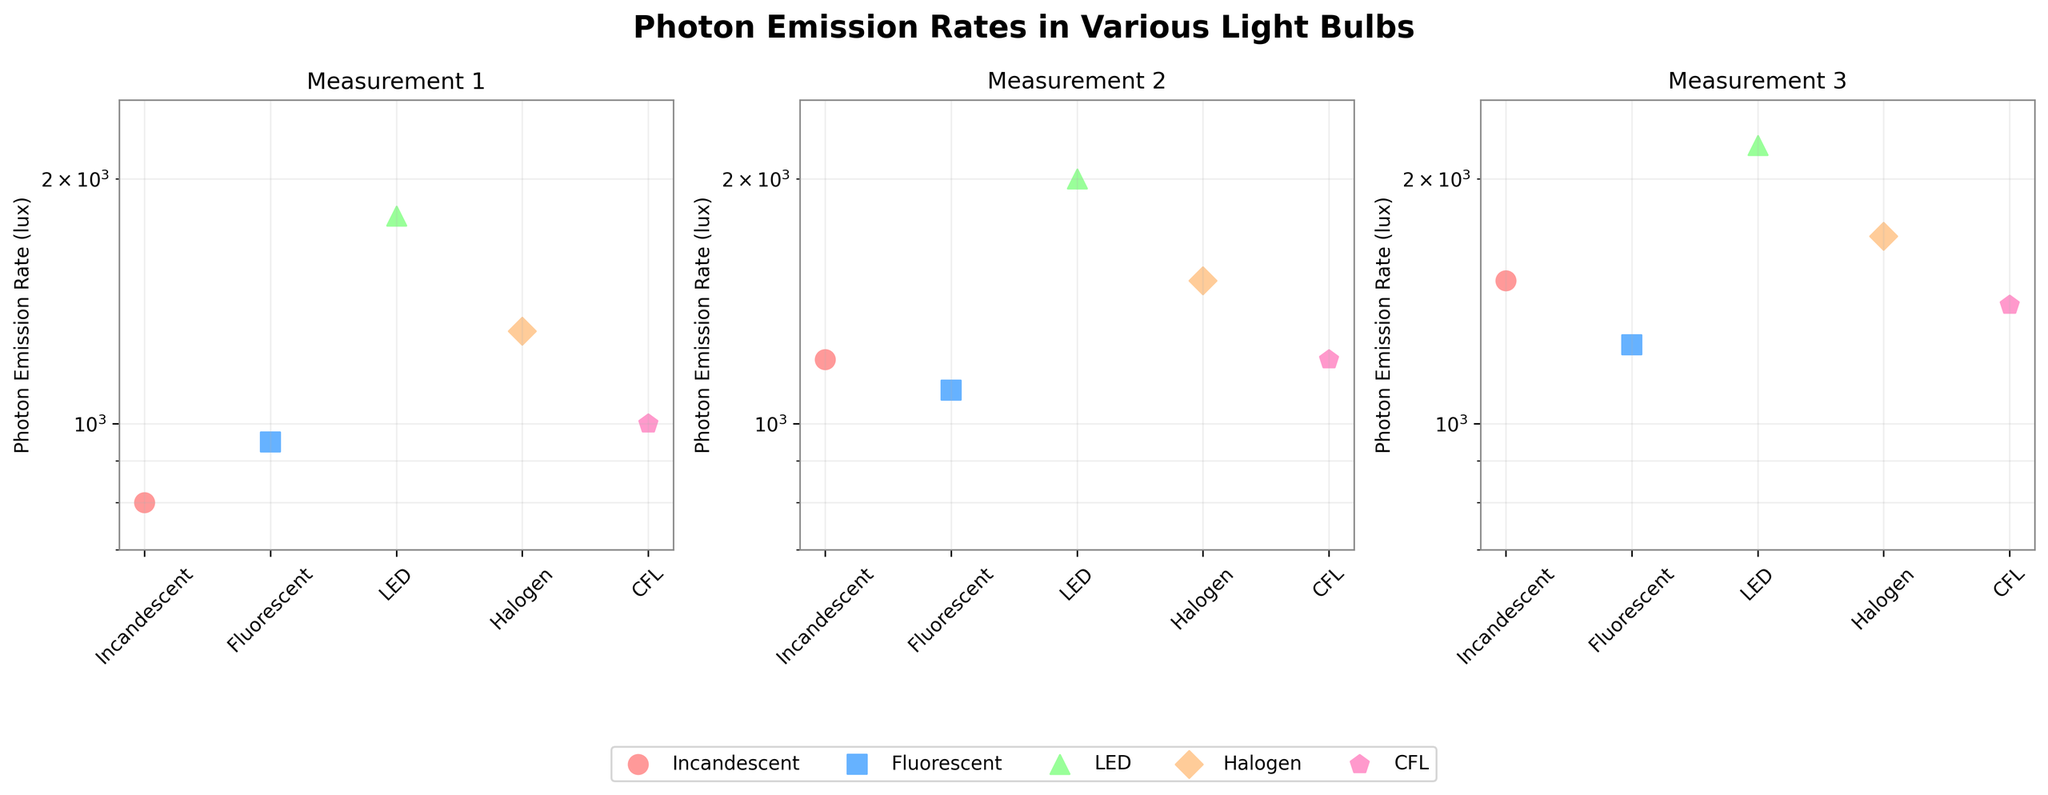What is the title of the figure? The title is usually located at the top of the figure, and in this case, it is "Photon Emission Rates in Various Light Bulbs".
Answer: Photon Emission Rates in Various Light Bulbs What does the y-axis represent in the subplots? The y-axis label indicates the measurement, which in this case is "Photon Emission Rate (lux)". Each subplot has this same y-axis label.
Answer: Photon Emission Rate (lux) Which light bulb type has the highest photon emission rate in Measurement 1? By examining the first subplot (Measurement 1), the LED light bulb has the highest photon emission rate, as indicated by the tallest point.
Answer: LED How many light bulb types are being compared? By counting the number of unique labels or markers in any subplot, we can see that there are five different light bulb types being compared.
Answer: Five Which light bulb type has the least variation in photon emission rates across all measurements? To find the least variation, compare the differences in photon emission rates across all three subplots for each light bulb type. The Fluorescent light bulb shows the least variation as its values are relatively close in each subplot.
Answer: Fluorescent What is the photon emission rate for the Halogen bulb in Measurement 2? In the second subplot (Measurement 2), locate the point corresponding to the Halogen bulb, which is labeled around 1500 lux on the y-axis.
Answer: 1500 lux Compare the photon emission rate of Incandescent and CFL bulbs in the third measurement. Which one is higher? In the third subplot (Measurement 3), observe the points for Incandescent and CFL bulbs. The Incandescent bulb has a photon emission rate of 1500 lux, whereas the CFL bulb has 1400 lux. Thus, Incandescent is higher.
Answer: Incandescent Which light bulb type shows a photon emission rate above 2000 lux? By looking at all subplots, the LED light bulb consistently shows photon emission rates above 2000 lux, particularly noted in Measurement 3.
Answer: LED Is there any light bulb type whose photon emission rate is below 900 lux in any measurements? By observing the lowest values on the y-axis in any of the subplots, we can see that none of the bulbs dip below 900 lux.
Answer: No Which light bulb type has a consistent increase in photon emission rate from Measurement 1 to Measurement 3? The LED light bulb shows a consistent increase, visible as sequentially higher points from Measurement 1 to Measurement 3.
Answer: LED 